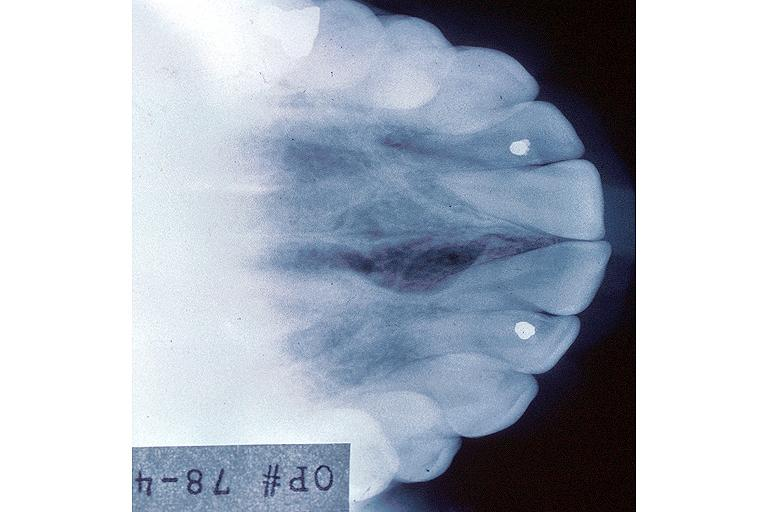does this image show incisive canal cyst nasopalatien duct cyst?
Answer the question using a single word or phrase. Yes 